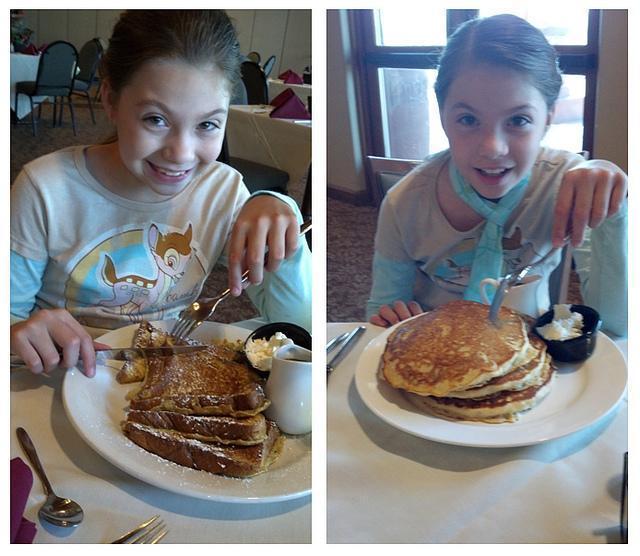How many pancakes are in the food stack?
Give a very brief answer. 3. How many bowls can be seen?
Give a very brief answer. 2. How many dining tables can be seen?
Give a very brief answer. 3. How many people are there?
Give a very brief answer. 2. How many chairs are there?
Give a very brief answer. 2. 